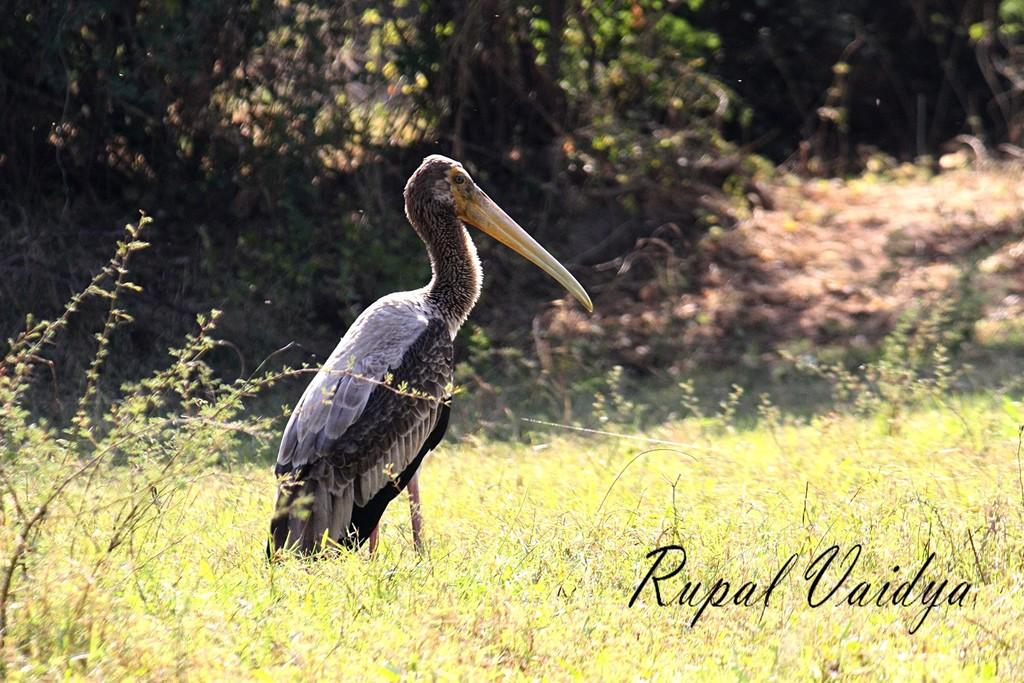What type of animal can be seen in the image? There is a bird in the image. What is the ground surface like in the image? There is grass on the ground in the image. What can be seen in the distance behind the bird? There are trees in the background of the image. What is present at the bottom of the image? There is text or writing at the bottom of the image. Can you hear the thunder in the image? There is no mention of thunder or any sound in the image, so it cannot be heard. 